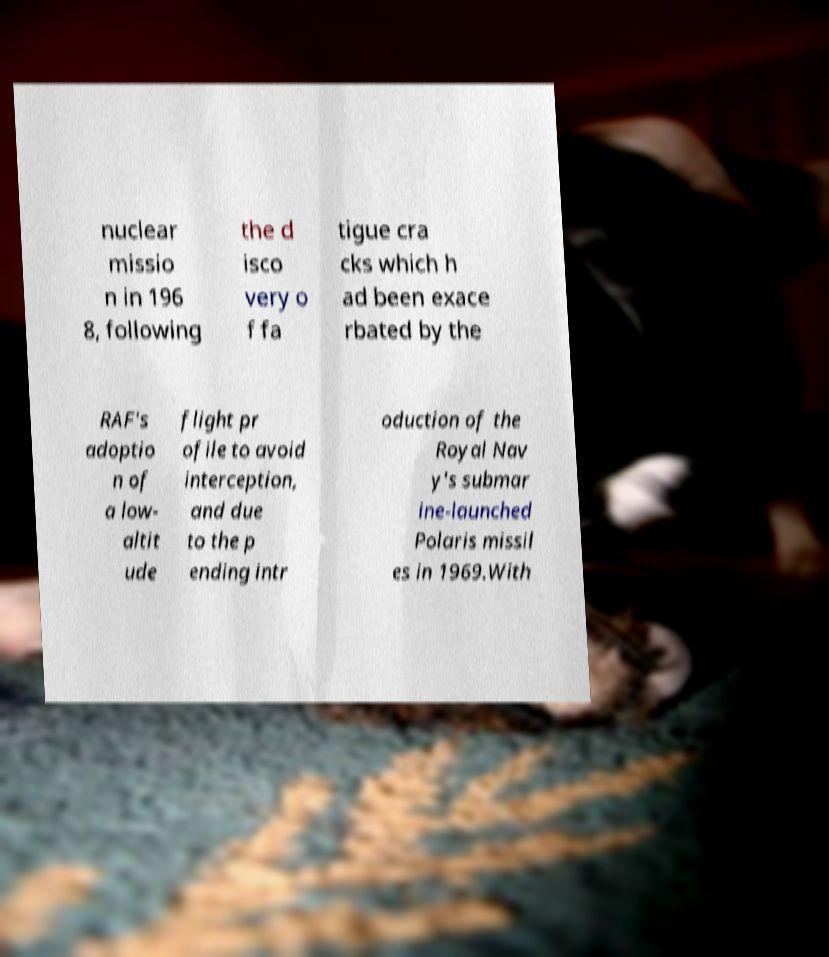Please read and relay the text visible in this image. What does it say? nuclear missio n in 196 8, following the d isco very o f fa tigue cra cks which h ad been exace rbated by the RAF's adoptio n of a low- altit ude flight pr ofile to avoid interception, and due to the p ending intr oduction of the Royal Nav y's submar ine-launched Polaris missil es in 1969.With 